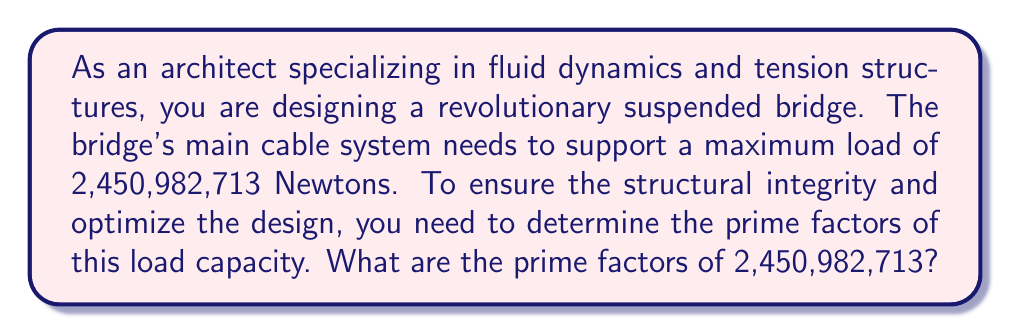Give your solution to this math problem. To find the prime factors of 2,450,982,713, we'll use the process of trial division:

1) First, let's try dividing by the smallest prime number, 2:
   $2,450,982,713 \div 2 = 1,225,491,356.5$ (not an integer)

2) Since 2 doesn't divide evenly, let's try the next prime number, 3:
   $2,450,982,713 \div 3 = 816,994,237.67$ (not an integer)

3) We continue this process with prime numbers up to the square root of 2,450,982,713:
   $\sqrt{2,450,982,713} \approx 49,507$

4) After trying several prime numbers, we find that 7 divides evenly:
   $2,450,982,713 \div 7 = 350,140,387$

5) Now we continue the process with 350,140,387:
   $350,140,387 \div 7 = 50,020,055$

6) Continuing:
   $50,020,055 \div 5 = 10,004,011$

7) 10,004,011 is itself a prime number, as it's not divisible by any prime up to its square root.

Therefore, the prime factorization is:

$$2,450,982,713 = 7 \times 7 \times 5 \times 10,004,011$$

This can be written in exponential notation as:

$$2,450,982,713 = 7^2 \times 5 \times 10,004,011$$

Understanding this prime factorization can help in designing the cable system, as it reveals the fundamental components of the load capacity. For instance, the factors of 7 and 5 might inform decisions about the number or arrangement of smaller support cables.
Answer: The prime factors of 2,450,982,713 are $7^2$, 5, and 10,004,011. 